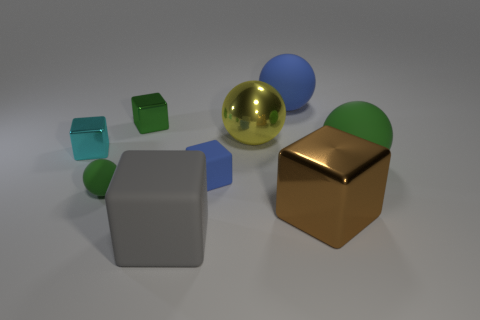Subtract all large green spheres. How many spheres are left? 3 Subtract all green balls. How many balls are left? 2 Add 1 large green cylinders. How many objects exist? 10 Subtract all balls. How many objects are left? 5 Subtract all yellow blocks. Subtract all red spheres. How many blocks are left? 5 Subtract 3 balls. How many balls are left? 1 Subtract all cyan cubes. How many green spheres are left? 2 Subtract all large purple metallic things. Subtract all cyan shiny blocks. How many objects are left? 8 Add 4 blue objects. How many blue objects are left? 6 Add 5 cyan blocks. How many cyan blocks exist? 6 